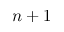Convert formula to latex. <formula><loc_0><loc_0><loc_500><loc_500>n + 1</formula> 